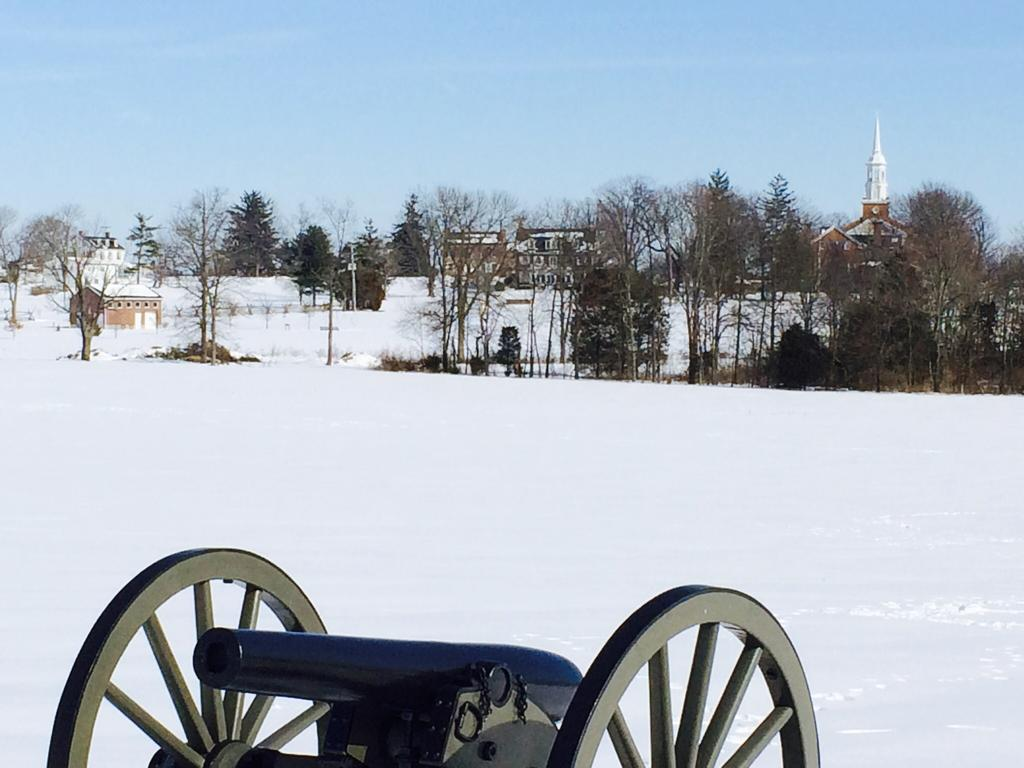What object is the main focus of the picture? There is a cannon wheel in the picture. What can be seen in the background of the picture? There are trees, buildings, and snow in the background of the picture. What is visible in the sky in the picture? The sky is visible in the background of the picture. Are there any windows visible in the picture? There is no mention of windows in the provided facts, so we cannot determine if any are present in the image. 